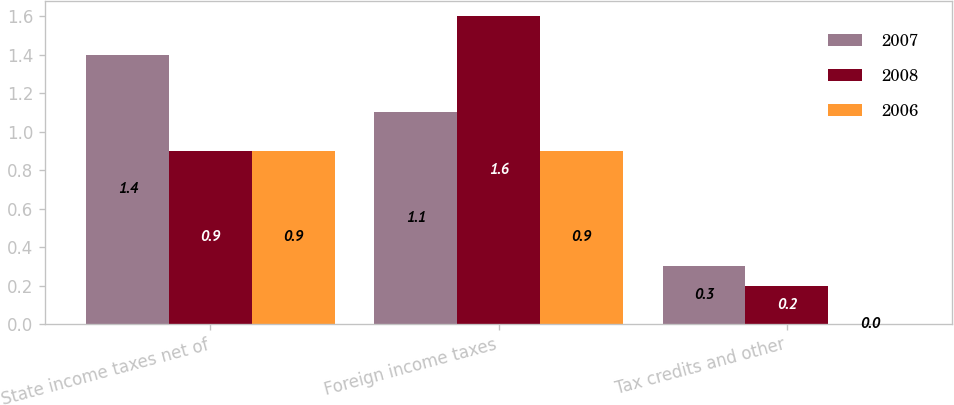Convert chart. <chart><loc_0><loc_0><loc_500><loc_500><stacked_bar_chart><ecel><fcel>State income taxes net of<fcel>Foreign income taxes<fcel>Tax credits and other<nl><fcel>2007<fcel>1.4<fcel>1.1<fcel>0.3<nl><fcel>2008<fcel>0.9<fcel>1.6<fcel>0.2<nl><fcel>2006<fcel>0.9<fcel>0.9<fcel>0<nl></chart> 